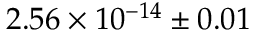<formula> <loc_0><loc_0><loc_500><loc_500>2 . 5 6 \times 1 0 ^ { - 1 4 } \pm 0 . 0 1</formula> 